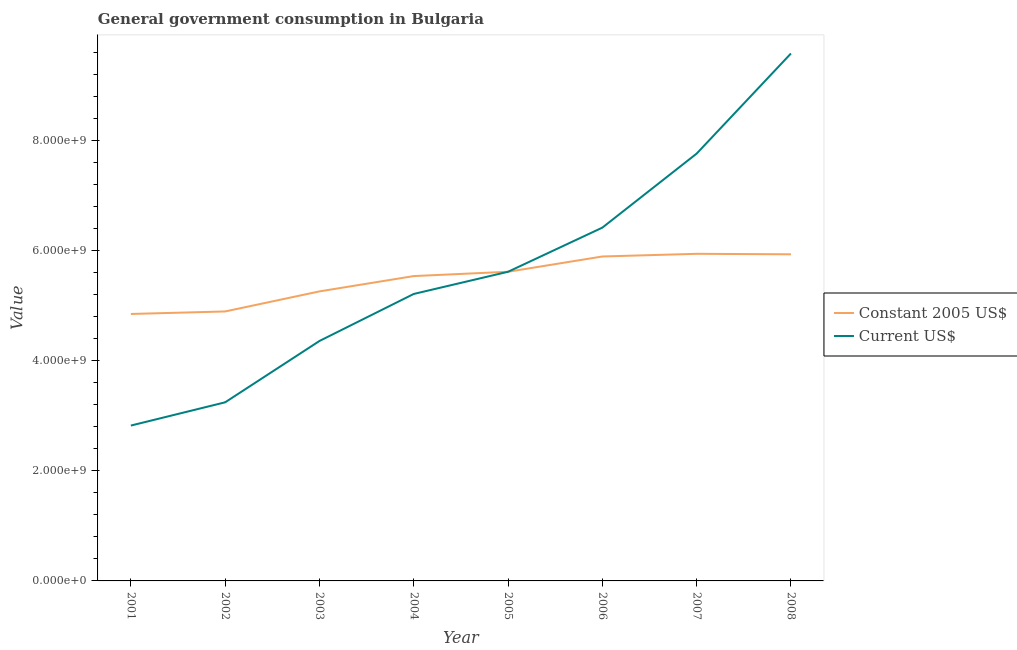Is the number of lines equal to the number of legend labels?
Ensure brevity in your answer.  Yes. What is the value consumed in constant 2005 us$ in 2006?
Provide a succinct answer. 5.89e+09. Across all years, what is the maximum value consumed in constant 2005 us$?
Your answer should be very brief. 5.94e+09. Across all years, what is the minimum value consumed in current us$?
Make the answer very short. 2.82e+09. In which year was the value consumed in current us$ minimum?
Ensure brevity in your answer.  2001. What is the total value consumed in current us$ in the graph?
Your response must be concise. 4.50e+1. What is the difference between the value consumed in constant 2005 us$ in 2004 and that in 2006?
Give a very brief answer. -3.56e+08. What is the difference between the value consumed in current us$ in 2002 and the value consumed in constant 2005 us$ in 2005?
Your answer should be very brief. -2.37e+09. What is the average value consumed in current us$ per year?
Your answer should be very brief. 5.63e+09. In the year 2006, what is the difference between the value consumed in constant 2005 us$ and value consumed in current us$?
Your response must be concise. -5.24e+08. In how many years, is the value consumed in current us$ greater than 1600000000?
Ensure brevity in your answer.  8. What is the ratio of the value consumed in constant 2005 us$ in 2005 to that in 2008?
Provide a succinct answer. 0.95. Is the value consumed in constant 2005 us$ in 2002 less than that in 2007?
Offer a terse response. Yes. What is the difference between the highest and the second highest value consumed in current us$?
Provide a short and direct response. 1.82e+09. What is the difference between the highest and the lowest value consumed in current us$?
Provide a succinct answer. 6.76e+09. Is the sum of the value consumed in constant 2005 us$ in 2007 and 2008 greater than the maximum value consumed in current us$ across all years?
Make the answer very short. Yes. Does the value consumed in constant 2005 us$ monotonically increase over the years?
Give a very brief answer. No. How many lines are there?
Keep it short and to the point. 2. How many years are there in the graph?
Make the answer very short. 8. Are the values on the major ticks of Y-axis written in scientific E-notation?
Provide a short and direct response. Yes. Does the graph contain any zero values?
Your response must be concise. No. Does the graph contain grids?
Offer a very short reply. No. What is the title of the graph?
Keep it short and to the point. General government consumption in Bulgaria. What is the label or title of the Y-axis?
Make the answer very short. Value. What is the Value in Constant 2005 US$ in 2001?
Offer a very short reply. 4.85e+09. What is the Value in Current US$ in 2001?
Provide a succinct answer. 2.82e+09. What is the Value in Constant 2005 US$ in 2002?
Ensure brevity in your answer.  4.89e+09. What is the Value in Current US$ in 2002?
Provide a short and direct response. 3.24e+09. What is the Value of Constant 2005 US$ in 2003?
Offer a terse response. 5.26e+09. What is the Value of Current US$ in 2003?
Offer a very short reply. 4.36e+09. What is the Value of Constant 2005 US$ in 2004?
Provide a short and direct response. 5.54e+09. What is the Value in Current US$ in 2004?
Ensure brevity in your answer.  5.21e+09. What is the Value in Constant 2005 US$ in 2005?
Keep it short and to the point. 5.61e+09. What is the Value in Current US$ in 2005?
Offer a terse response. 5.61e+09. What is the Value in Constant 2005 US$ in 2006?
Provide a short and direct response. 5.89e+09. What is the Value of Current US$ in 2006?
Your answer should be very brief. 6.42e+09. What is the Value of Constant 2005 US$ in 2007?
Your answer should be compact. 5.94e+09. What is the Value of Current US$ in 2007?
Ensure brevity in your answer.  7.76e+09. What is the Value of Constant 2005 US$ in 2008?
Make the answer very short. 5.93e+09. What is the Value in Current US$ in 2008?
Make the answer very short. 9.58e+09. Across all years, what is the maximum Value of Constant 2005 US$?
Give a very brief answer. 5.94e+09. Across all years, what is the maximum Value in Current US$?
Offer a very short reply. 9.58e+09. Across all years, what is the minimum Value in Constant 2005 US$?
Keep it short and to the point. 4.85e+09. Across all years, what is the minimum Value in Current US$?
Keep it short and to the point. 2.82e+09. What is the total Value of Constant 2005 US$ in the graph?
Give a very brief answer. 4.39e+1. What is the total Value of Current US$ in the graph?
Your answer should be very brief. 4.50e+1. What is the difference between the Value in Constant 2005 US$ in 2001 and that in 2002?
Your response must be concise. -4.58e+07. What is the difference between the Value of Current US$ in 2001 and that in 2002?
Ensure brevity in your answer.  -4.22e+08. What is the difference between the Value in Constant 2005 US$ in 2001 and that in 2003?
Your answer should be very brief. -4.10e+08. What is the difference between the Value of Current US$ in 2001 and that in 2003?
Provide a short and direct response. -1.54e+09. What is the difference between the Value in Constant 2005 US$ in 2001 and that in 2004?
Ensure brevity in your answer.  -6.88e+08. What is the difference between the Value in Current US$ in 2001 and that in 2004?
Your answer should be compact. -2.39e+09. What is the difference between the Value of Constant 2005 US$ in 2001 and that in 2005?
Provide a short and direct response. -7.66e+08. What is the difference between the Value in Current US$ in 2001 and that in 2005?
Your answer should be very brief. -2.79e+09. What is the difference between the Value in Constant 2005 US$ in 2001 and that in 2006?
Offer a very short reply. -1.04e+09. What is the difference between the Value in Current US$ in 2001 and that in 2006?
Provide a short and direct response. -3.60e+09. What is the difference between the Value in Constant 2005 US$ in 2001 and that in 2007?
Ensure brevity in your answer.  -1.09e+09. What is the difference between the Value of Current US$ in 2001 and that in 2007?
Make the answer very short. -4.94e+09. What is the difference between the Value of Constant 2005 US$ in 2001 and that in 2008?
Ensure brevity in your answer.  -1.08e+09. What is the difference between the Value in Current US$ in 2001 and that in 2008?
Make the answer very short. -6.76e+09. What is the difference between the Value of Constant 2005 US$ in 2002 and that in 2003?
Provide a succinct answer. -3.64e+08. What is the difference between the Value in Current US$ in 2002 and that in 2003?
Your answer should be very brief. -1.11e+09. What is the difference between the Value in Constant 2005 US$ in 2002 and that in 2004?
Your answer should be very brief. -6.42e+08. What is the difference between the Value in Current US$ in 2002 and that in 2004?
Your answer should be compact. -1.97e+09. What is the difference between the Value in Constant 2005 US$ in 2002 and that in 2005?
Offer a terse response. -7.21e+08. What is the difference between the Value of Current US$ in 2002 and that in 2005?
Make the answer very short. -2.37e+09. What is the difference between the Value in Constant 2005 US$ in 2002 and that in 2006?
Provide a short and direct response. -9.98e+08. What is the difference between the Value in Current US$ in 2002 and that in 2006?
Give a very brief answer. -3.17e+09. What is the difference between the Value in Constant 2005 US$ in 2002 and that in 2007?
Provide a succinct answer. -1.05e+09. What is the difference between the Value of Current US$ in 2002 and that in 2007?
Your answer should be very brief. -4.52e+09. What is the difference between the Value of Constant 2005 US$ in 2002 and that in 2008?
Provide a short and direct response. -1.04e+09. What is the difference between the Value of Current US$ in 2002 and that in 2008?
Keep it short and to the point. -6.34e+09. What is the difference between the Value of Constant 2005 US$ in 2003 and that in 2004?
Provide a short and direct response. -2.78e+08. What is the difference between the Value of Current US$ in 2003 and that in 2004?
Provide a succinct answer. -8.54e+08. What is the difference between the Value in Constant 2005 US$ in 2003 and that in 2005?
Provide a succinct answer. -3.56e+08. What is the difference between the Value in Current US$ in 2003 and that in 2005?
Give a very brief answer. -1.26e+09. What is the difference between the Value of Constant 2005 US$ in 2003 and that in 2006?
Offer a very short reply. -6.34e+08. What is the difference between the Value in Current US$ in 2003 and that in 2006?
Ensure brevity in your answer.  -2.06e+09. What is the difference between the Value in Constant 2005 US$ in 2003 and that in 2007?
Your answer should be very brief. -6.83e+08. What is the difference between the Value in Current US$ in 2003 and that in 2007?
Your answer should be compact. -3.40e+09. What is the difference between the Value of Constant 2005 US$ in 2003 and that in 2008?
Your response must be concise. -6.74e+08. What is the difference between the Value in Current US$ in 2003 and that in 2008?
Ensure brevity in your answer.  -5.22e+09. What is the difference between the Value in Constant 2005 US$ in 2004 and that in 2005?
Offer a very short reply. -7.82e+07. What is the difference between the Value in Current US$ in 2004 and that in 2005?
Make the answer very short. -4.03e+08. What is the difference between the Value of Constant 2005 US$ in 2004 and that in 2006?
Provide a succinct answer. -3.56e+08. What is the difference between the Value of Current US$ in 2004 and that in 2006?
Keep it short and to the point. -1.20e+09. What is the difference between the Value in Constant 2005 US$ in 2004 and that in 2007?
Ensure brevity in your answer.  -4.04e+08. What is the difference between the Value in Current US$ in 2004 and that in 2007?
Provide a short and direct response. -2.55e+09. What is the difference between the Value of Constant 2005 US$ in 2004 and that in 2008?
Your response must be concise. -3.95e+08. What is the difference between the Value in Current US$ in 2004 and that in 2008?
Keep it short and to the point. -4.37e+09. What is the difference between the Value of Constant 2005 US$ in 2005 and that in 2006?
Offer a terse response. -2.78e+08. What is the difference between the Value of Current US$ in 2005 and that in 2006?
Make the answer very short. -8.02e+08. What is the difference between the Value in Constant 2005 US$ in 2005 and that in 2007?
Your response must be concise. -3.26e+08. What is the difference between the Value of Current US$ in 2005 and that in 2007?
Provide a short and direct response. -2.15e+09. What is the difference between the Value of Constant 2005 US$ in 2005 and that in 2008?
Your answer should be very brief. -3.17e+08. What is the difference between the Value in Current US$ in 2005 and that in 2008?
Make the answer very short. -3.96e+09. What is the difference between the Value in Constant 2005 US$ in 2006 and that in 2007?
Provide a short and direct response. -4.85e+07. What is the difference between the Value of Current US$ in 2006 and that in 2007?
Your response must be concise. -1.34e+09. What is the difference between the Value in Constant 2005 US$ in 2006 and that in 2008?
Your answer should be compact. -3.97e+07. What is the difference between the Value of Current US$ in 2006 and that in 2008?
Your answer should be compact. -3.16e+09. What is the difference between the Value in Constant 2005 US$ in 2007 and that in 2008?
Your response must be concise. 8.86e+06. What is the difference between the Value in Current US$ in 2007 and that in 2008?
Offer a terse response. -1.82e+09. What is the difference between the Value in Constant 2005 US$ in 2001 and the Value in Current US$ in 2002?
Your response must be concise. 1.60e+09. What is the difference between the Value in Constant 2005 US$ in 2001 and the Value in Current US$ in 2003?
Your answer should be compact. 4.91e+08. What is the difference between the Value of Constant 2005 US$ in 2001 and the Value of Current US$ in 2004?
Offer a terse response. -3.64e+08. What is the difference between the Value of Constant 2005 US$ in 2001 and the Value of Current US$ in 2005?
Offer a terse response. -7.66e+08. What is the difference between the Value in Constant 2005 US$ in 2001 and the Value in Current US$ in 2006?
Your response must be concise. -1.57e+09. What is the difference between the Value in Constant 2005 US$ in 2001 and the Value in Current US$ in 2007?
Keep it short and to the point. -2.91e+09. What is the difference between the Value in Constant 2005 US$ in 2001 and the Value in Current US$ in 2008?
Keep it short and to the point. -4.73e+09. What is the difference between the Value of Constant 2005 US$ in 2002 and the Value of Current US$ in 2003?
Offer a terse response. 5.36e+08. What is the difference between the Value in Constant 2005 US$ in 2002 and the Value in Current US$ in 2004?
Your answer should be very brief. -3.18e+08. What is the difference between the Value of Constant 2005 US$ in 2002 and the Value of Current US$ in 2005?
Offer a very short reply. -7.21e+08. What is the difference between the Value of Constant 2005 US$ in 2002 and the Value of Current US$ in 2006?
Keep it short and to the point. -1.52e+09. What is the difference between the Value in Constant 2005 US$ in 2002 and the Value in Current US$ in 2007?
Keep it short and to the point. -2.87e+09. What is the difference between the Value of Constant 2005 US$ in 2002 and the Value of Current US$ in 2008?
Provide a short and direct response. -4.69e+09. What is the difference between the Value of Constant 2005 US$ in 2003 and the Value of Current US$ in 2004?
Your answer should be very brief. 4.65e+07. What is the difference between the Value in Constant 2005 US$ in 2003 and the Value in Current US$ in 2005?
Your answer should be compact. -3.56e+08. What is the difference between the Value of Constant 2005 US$ in 2003 and the Value of Current US$ in 2006?
Offer a very short reply. -1.16e+09. What is the difference between the Value of Constant 2005 US$ in 2003 and the Value of Current US$ in 2007?
Your response must be concise. -2.50e+09. What is the difference between the Value of Constant 2005 US$ in 2003 and the Value of Current US$ in 2008?
Keep it short and to the point. -4.32e+09. What is the difference between the Value of Constant 2005 US$ in 2004 and the Value of Current US$ in 2005?
Your answer should be compact. -7.82e+07. What is the difference between the Value in Constant 2005 US$ in 2004 and the Value in Current US$ in 2006?
Your answer should be very brief. -8.80e+08. What is the difference between the Value of Constant 2005 US$ in 2004 and the Value of Current US$ in 2007?
Make the answer very short. -2.22e+09. What is the difference between the Value of Constant 2005 US$ in 2004 and the Value of Current US$ in 2008?
Provide a succinct answer. -4.04e+09. What is the difference between the Value of Constant 2005 US$ in 2005 and the Value of Current US$ in 2006?
Offer a very short reply. -8.02e+08. What is the difference between the Value of Constant 2005 US$ in 2005 and the Value of Current US$ in 2007?
Provide a short and direct response. -2.15e+09. What is the difference between the Value in Constant 2005 US$ in 2005 and the Value in Current US$ in 2008?
Offer a very short reply. -3.96e+09. What is the difference between the Value in Constant 2005 US$ in 2006 and the Value in Current US$ in 2007?
Provide a short and direct response. -1.87e+09. What is the difference between the Value of Constant 2005 US$ in 2006 and the Value of Current US$ in 2008?
Your answer should be very brief. -3.69e+09. What is the difference between the Value in Constant 2005 US$ in 2007 and the Value in Current US$ in 2008?
Keep it short and to the point. -3.64e+09. What is the average Value of Constant 2005 US$ per year?
Provide a short and direct response. 5.49e+09. What is the average Value of Current US$ per year?
Offer a terse response. 5.63e+09. In the year 2001, what is the difference between the Value in Constant 2005 US$ and Value in Current US$?
Offer a terse response. 2.03e+09. In the year 2002, what is the difference between the Value in Constant 2005 US$ and Value in Current US$?
Give a very brief answer. 1.65e+09. In the year 2003, what is the difference between the Value of Constant 2005 US$ and Value of Current US$?
Ensure brevity in your answer.  9.01e+08. In the year 2004, what is the difference between the Value of Constant 2005 US$ and Value of Current US$?
Keep it short and to the point. 3.25e+08. In the year 2006, what is the difference between the Value in Constant 2005 US$ and Value in Current US$?
Offer a terse response. -5.24e+08. In the year 2007, what is the difference between the Value of Constant 2005 US$ and Value of Current US$?
Provide a short and direct response. -1.82e+09. In the year 2008, what is the difference between the Value in Constant 2005 US$ and Value in Current US$?
Your response must be concise. -3.65e+09. What is the ratio of the Value in Constant 2005 US$ in 2001 to that in 2002?
Make the answer very short. 0.99. What is the ratio of the Value in Current US$ in 2001 to that in 2002?
Offer a terse response. 0.87. What is the ratio of the Value in Constant 2005 US$ in 2001 to that in 2003?
Your answer should be very brief. 0.92. What is the ratio of the Value of Current US$ in 2001 to that in 2003?
Your response must be concise. 0.65. What is the ratio of the Value in Constant 2005 US$ in 2001 to that in 2004?
Give a very brief answer. 0.88. What is the ratio of the Value in Current US$ in 2001 to that in 2004?
Ensure brevity in your answer.  0.54. What is the ratio of the Value in Constant 2005 US$ in 2001 to that in 2005?
Ensure brevity in your answer.  0.86. What is the ratio of the Value of Current US$ in 2001 to that in 2005?
Offer a terse response. 0.5. What is the ratio of the Value of Constant 2005 US$ in 2001 to that in 2006?
Offer a very short reply. 0.82. What is the ratio of the Value of Current US$ in 2001 to that in 2006?
Your response must be concise. 0.44. What is the ratio of the Value in Constant 2005 US$ in 2001 to that in 2007?
Make the answer very short. 0.82. What is the ratio of the Value in Current US$ in 2001 to that in 2007?
Your answer should be compact. 0.36. What is the ratio of the Value in Constant 2005 US$ in 2001 to that in 2008?
Make the answer very short. 0.82. What is the ratio of the Value of Current US$ in 2001 to that in 2008?
Make the answer very short. 0.29. What is the ratio of the Value of Constant 2005 US$ in 2002 to that in 2003?
Offer a terse response. 0.93. What is the ratio of the Value of Current US$ in 2002 to that in 2003?
Keep it short and to the point. 0.74. What is the ratio of the Value in Constant 2005 US$ in 2002 to that in 2004?
Your response must be concise. 0.88. What is the ratio of the Value in Current US$ in 2002 to that in 2004?
Offer a very short reply. 0.62. What is the ratio of the Value of Constant 2005 US$ in 2002 to that in 2005?
Offer a very short reply. 0.87. What is the ratio of the Value in Current US$ in 2002 to that in 2005?
Your answer should be very brief. 0.58. What is the ratio of the Value of Constant 2005 US$ in 2002 to that in 2006?
Your answer should be compact. 0.83. What is the ratio of the Value of Current US$ in 2002 to that in 2006?
Ensure brevity in your answer.  0.51. What is the ratio of the Value in Constant 2005 US$ in 2002 to that in 2007?
Your answer should be very brief. 0.82. What is the ratio of the Value in Current US$ in 2002 to that in 2007?
Offer a terse response. 0.42. What is the ratio of the Value in Constant 2005 US$ in 2002 to that in 2008?
Offer a terse response. 0.82. What is the ratio of the Value in Current US$ in 2002 to that in 2008?
Make the answer very short. 0.34. What is the ratio of the Value of Constant 2005 US$ in 2003 to that in 2004?
Offer a terse response. 0.95. What is the ratio of the Value of Current US$ in 2003 to that in 2004?
Your answer should be compact. 0.84. What is the ratio of the Value of Constant 2005 US$ in 2003 to that in 2005?
Ensure brevity in your answer.  0.94. What is the ratio of the Value in Current US$ in 2003 to that in 2005?
Offer a very short reply. 0.78. What is the ratio of the Value of Constant 2005 US$ in 2003 to that in 2006?
Give a very brief answer. 0.89. What is the ratio of the Value in Current US$ in 2003 to that in 2006?
Keep it short and to the point. 0.68. What is the ratio of the Value of Constant 2005 US$ in 2003 to that in 2007?
Offer a very short reply. 0.89. What is the ratio of the Value in Current US$ in 2003 to that in 2007?
Your answer should be very brief. 0.56. What is the ratio of the Value in Constant 2005 US$ in 2003 to that in 2008?
Offer a terse response. 0.89. What is the ratio of the Value in Current US$ in 2003 to that in 2008?
Keep it short and to the point. 0.45. What is the ratio of the Value of Constant 2005 US$ in 2004 to that in 2005?
Give a very brief answer. 0.99. What is the ratio of the Value of Current US$ in 2004 to that in 2005?
Your answer should be very brief. 0.93. What is the ratio of the Value of Constant 2005 US$ in 2004 to that in 2006?
Offer a very short reply. 0.94. What is the ratio of the Value of Current US$ in 2004 to that in 2006?
Offer a very short reply. 0.81. What is the ratio of the Value of Constant 2005 US$ in 2004 to that in 2007?
Your response must be concise. 0.93. What is the ratio of the Value of Current US$ in 2004 to that in 2007?
Provide a succinct answer. 0.67. What is the ratio of the Value of Constant 2005 US$ in 2004 to that in 2008?
Your answer should be compact. 0.93. What is the ratio of the Value of Current US$ in 2004 to that in 2008?
Provide a short and direct response. 0.54. What is the ratio of the Value of Constant 2005 US$ in 2005 to that in 2006?
Your response must be concise. 0.95. What is the ratio of the Value in Current US$ in 2005 to that in 2006?
Keep it short and to the point. 0.88. What is the ratio of the Value in Constant 2005 US$ in 2005 to that in 2007?
Offer a terse response. 0.95. What is the ratio of the Value in Current US$ in 2005 to that in 2007?
Your answer should be very brief. 0.72. What is the ratio of the Value of Constant 2005 US$ in 2005 to that in 2008?
Offer a terse response. 0.95. What is the ratio of the Value in Current US$ in 2005 to that in 2008?
Your answer should be compact. 0.59. What is the ratio of the Value in Current US$ in 2006 to that in 2007?
Provide a short and direct response. 0.83. What is the ratio of the Value of Constant 2005 US$ in 2006 to that in 2008?
Your response must be concise. 0.99. What is the ratio of the Value in Current US$ in 2006 to that in 2008?
Provide a succinct answer. 0.67. What is the ratio of the Value of Constant 2005 US$ in 2007 to that in 2008?
Provide a short and direct response. 1. What is the ratio of the Value of Current US$ in 2007 to that in 2008?
Give a very brief answer. 0.81. What is the difference between the highest and the second highest Value of Constant 2005 US$?
Keep it short and to the point. 8.86e+06. What is the difference between the highest and the second highest Value in Current US$?
Provide a short and direct response. 1.82e+09. What is the difference between the highest and the lowest Value in Constant 2005 US$?
Ensure brevity in your answer.  1.09e+09. What is the difference between the highest and the lowest Value in Current US$?
Give a very brief answer. 6.76e+09. 